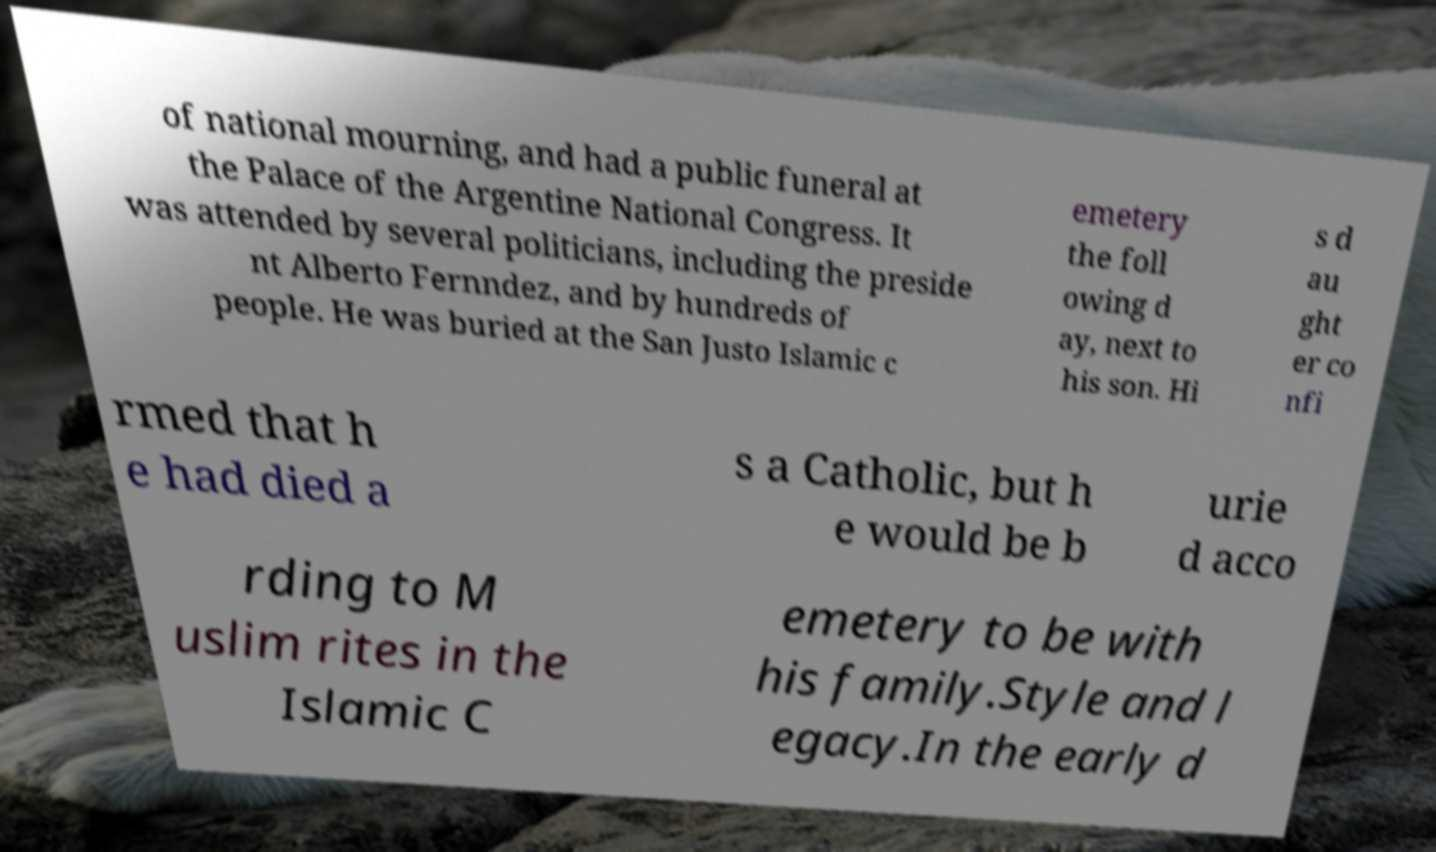Can you accurately transcribe the text from the provided image for me? of national mourning, and had a public funeral at the Palace of the Argentine National Congress. It was attended by several politicians, including the preside nt Alberto Fernndez, and by hundreds of people. He was buried at the San Justo Islamic c emetery the foll owing d ay, next to his son. Hi s d au ght er co nfi rmed that h e had died a s a Catholic, but h e would be b urie d acco rding to M uslim rites in the Islamic C emetery to be with his family.Style and l egacy.In the early d 